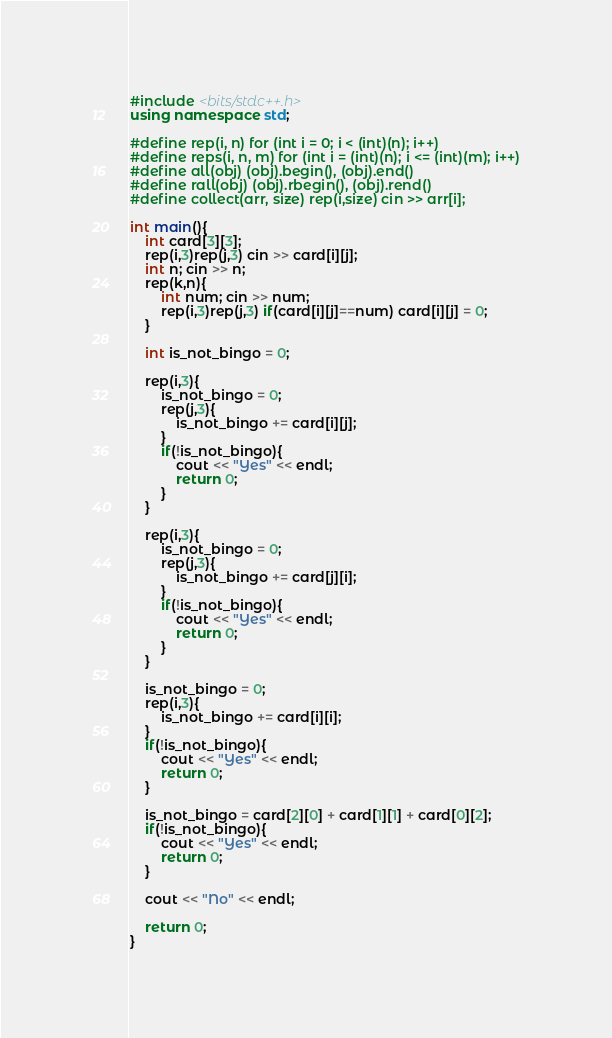Convert code to text. <code><loc_0><loc_0><loc_500><loc_500><_C++_>#include <bits/stdc++.h>
using namespace std;

#define rep(i, n) for (int i = 0; i < (int)(n); i++)
#define reps(i, n, m) for (int i = (int)(n); i <= (int)(m); i++)
#define all(obj) (obj).begin(), (obj).end()
#define rall(obj) (obj).rbegin(), (obj).rend()
#define collect(arr, size) rep(i,size) cin >> arr[i];

int main(){
    int card[3][3];
    rep(i,3)rep(j,3) cin >> card[i][j];
    int n; cin >> n;
    rep(k,n){
        int num; cin >> num;
        rep(i,3)rep(j,3) if(card[i][j]==num) card[i][j] = 0;
    }
    
    int is_not_bingo = 0;
    
    rep(i,3){
        is_not_bingo = 0;
        rep(j,3){
            is_not_bingo += card[i][j];
        }
        if(!is_not_bingo){
            cout << "Yes" << endl;
            return 0;
        }
    }
    
    rep(i,3){
        is_not_bingo = 0;
        rep(j,3){
            is_not_bingo += card[j][i];
        }
        if(!is_not_bingo){
            cout << "Yes" << endl;
            return 0;
        }
    }
    
    is_not_bingo = 0;
    rep(i,3){
        is_not_bingo += card[i][i];
    }
    if(!is_not_bingo){
        cout << "Yes" << endl;
        return 0;
    }
    
    is_not_bingo = card[2][0] + card[1][1] + card[0][2];
    if(!is_not_bingo){
        cout << "Yes" << endl;
        return 0;
    }
    
    cout << "No" << endl;
    
    return 0;
}</code> 